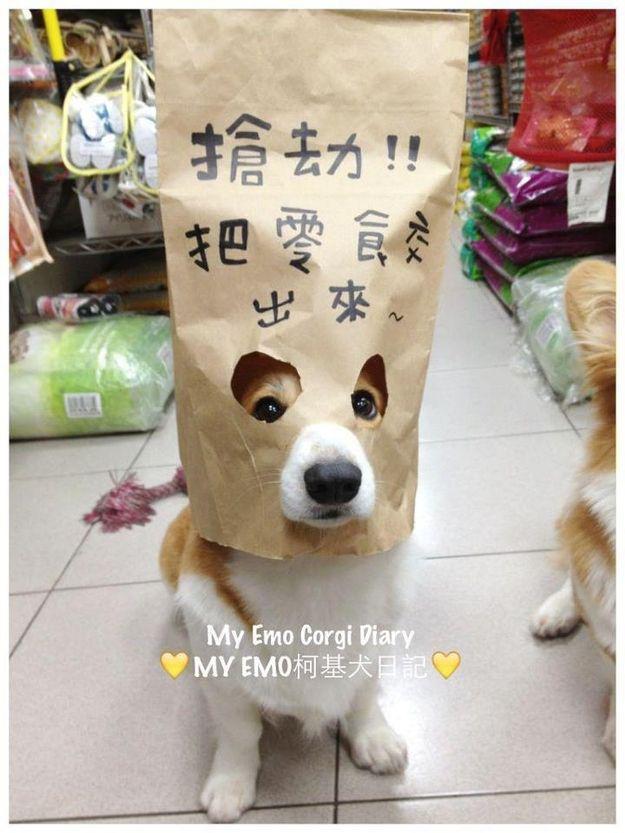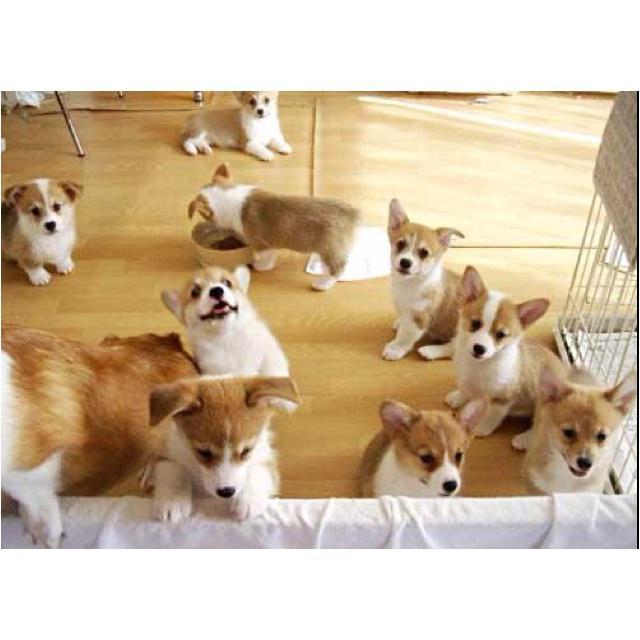The first image is the image on the left, the second image is the image on the right. Assess this claim about the two images: "Both images feature the same number of dogs.". Correct or not? Answer yes or no. No. The first image is the image on the left, the second image is the image on the right. Given the left and right images, does the statement "A corgi wearing a tie around his neck is behind a table with his front paws propped on its edge." hold true? Answer yes or no. No. 